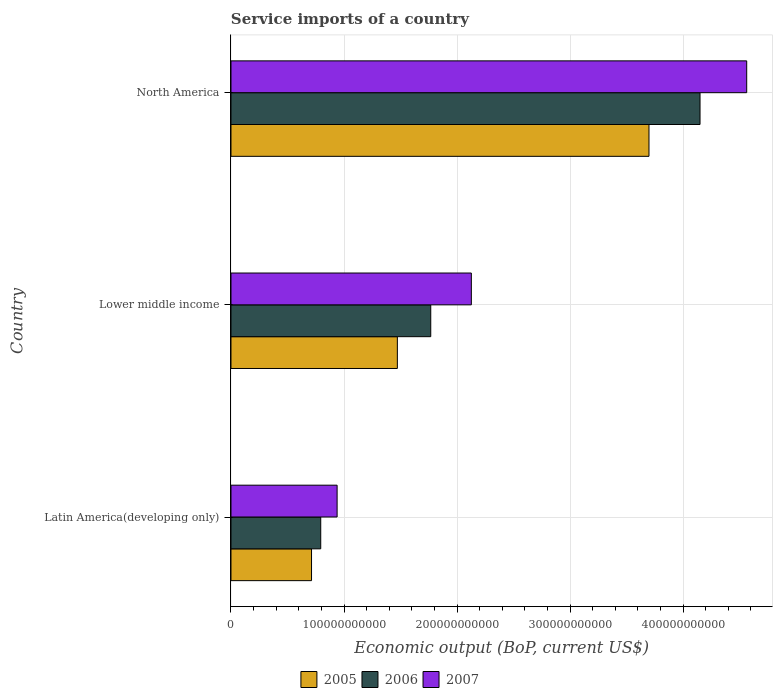How many different coloured bars are there?
Provide a short and direct response. 3. How many groups of bars are there?
Give a very brief answer. 3. Are the number of bars per tick equal to the number of legend labels?
Provide a short and direct response. Yes. What is the service imports in 2006 in Lower middle income?
Ensure brevity in your answer.  1.77e+11. Across all countries, what is the maximum service imports in 2005?
Keep it short and to the point. 3.70e+11. Across all countries, what is the minimum service imports in 2005?
Give a very brief answer. 7.13e+1. In which country was the service imports in 2005 minimum?
Offer a very short reply. Latin America(developing only). What is the total service imports in 2005 in the graph?
Offer a terse response. 5.88e+11. What is the difference between the service imports in 2006 in Lower middle income and that in North America?
Make the answer very short. -2.38e+11. What is the difference between the service imports in 2007 in Lower middle income and the service imports in 2006 in North America?
Offer a terse response. -2.02e+11. What is the average service imports in 2005 per country?
Give a very brief answer. 1.96e+11. What is the difference between the service imports in 2006 and service imports in 2007 in North America?
Ensure brevity in your answer.  -4.13e+1. In how many countries, is the service imports in 2007 greater than 440000000000 US$?
Give a very brief answer. 1. What is the ratio of the service imports in 2005 in Latin America(developing only) to that in North America?
Offer a very short reply. 0.19. Is the service imports in 2005 in Latin America(developing only) less than that in Lower middle income?
Your answer should be very brief. Yes. What is the difference between the highest and the second highest service imports in 2007?
Provide a succinct answer. 2.44e+11. What is the difference between the highest and the lowest service imports in 2007?
Provide a short and direct response. 3.62e+11. In how many countries, is the service imports in 2005 greater than the average service imports in 2005 taken over all countries?
Your answer should be compact. 1. Is it the case that in every country, the sum of the service imports in 2007 and service imports in 2005 is greater than the service imports in 2006?
Provide a succinct answer. Yes. What is the difference between two consecutive major ticks on the X-axis?
Keep it short and to the point. 1.00e+11. Does the graph contain any zero values?
Offer a very short reply. No. How are the legend labels stacked?
Keep it short and to the point. Horizontal. What is the title of the graph?
Provide a succinct answer. Service imports of a country. What is the label or title of the X-axis?
Your answer should be very brief. Economic output (BoP, current US$). What is the label or title of the Y-axis?
Keep it short and to the point. Country. What is the Economic output (BoP, current US$) in 2005 in Latin America(developing only)?
Offer a terse response. 7.13e+1. What is the Economic output (BoP, current US$) in 2006 in Latin America(developing only)?
Make the answer very short. 7.94e+1. What is the Economic output (BoP, current US$) in 2007 in Latin America(developing only)?
Offer a very short reply. 9.39e+1. What is the Economic output (BoP, current US$) in 2005 in Lower middle income?
Your answer should be very brief. 1.47e+11. What is the Economic output (BoP, current US$) in 2006 in Lower middle income?
Keep it short and to the point. 1.77e+11. What is the Economic output (BoP, current US$) of 2007 in Lower middle income?
Ensure brevity in your answer.  2.13e+11. What is the Economic output (BoP, current US$) in 2005 in North America?
Make the answer very short. 3.70e+11. What is the Economic output (BoP, current US$) in 2006 in North America?
Provide a short and direct response. 4.15e+11. What is the Economic output (BoP, current US$) in 2007 in North America?
Ensure brevity in your answer.  4.56e+11. Across all countries, what is the maximum Economic output (BoP, current US$) of 2005?
Your response must be concise. 3.70e+11. Across all countries, what is the maximum Economic output (BoP, current US$) of 2006?
Provide a short and direct response. 4.15e+11. Across all countries, what is the maximum Economic output (BoP, current US$) in 2007?
Offer a very short reply. 4.56e+11. Across all countries, what is the minimum Economic output (BoP, current US$) in 2005?
Make the answer very short. 7.13e+1. Across all countries, what is the minimum Economic output (BoP, current US$) of 2006?
Provide a succinct answer. 7.94e+1. Across all countries, what is the minimum Economic output (BoP, current US$) of 2007?
Make the answer very short. 9.39e+1. What is the total Economic output (BoP, current US$) of 2005 in the graph?
Your response must be concise. 5.88e+11. What is the total Economic output (BoP, current US$) of 2006 in the graph?
Your answer should be compact. 6.71e+11. What is the total Economic output (BoP, current US$) of 2007 in the graph?
Keep it short and to the point. 7.63e+11. What is the difference between the Economic output (BoP, current US$) in 2005 in Latin America(developing only) and that in Lower middle income?
Provide a succinct answer. -7.59e+1. What is the difference between the Economic output (BoP, current US$) of 2006 in Latin America(developing only) and that in Lower middle income?
Keep it short and to the point. -9.73e+1. What is the difference between the Economic output (BoP, current US$) in 2007 in Latin America(developing only) and that in Lower middle income?
Provide a succinct answer. -1.19e+11. What is the difference between the Economic output (BoP, current US$) in 2005 in Latin America(developing only) and that in North America?
Your response must be concise. -2.99e+11. What is the difference between the Economic output (BoP, current US$) of 2006 in Latin America(developing only) and that in North America?
Offer a very short reply. -3.36e+11. What is the difference between the Economic output (BoP, current US$) in 2007 in Latin America(developing only) and that in North America?
Provide a succinct answer. -3.62e+11. What is the difference between the Economic output (BoP, current US$) in 2005 in Lower middle income and that in North America?
Make the answer very short. -2.23e+11. What is the difference between the Economic output (BoP, current US$) in 2006 in Lower middle income and that in North America?
Your response must be concise. -2.38e+11. What is the difference between the Economic output (BoP, current US$) of 2007 in Lower middle income and that in North America?
Offer a terse response. -2.44e+11. What is the difference between the Economic output (BoP, current US$) in 2005 in Latin America(developing only) and the Economic output (BoP, current US$) in 2006 in Lower middle income?
Provide a succinct answer. -1.05e+11. What is the difference between the Economic output (BoP, current US$) of 2005 in Latin America(developing only) and the Economic output (BoP, current US$) of 2007 in Lower middle income?
Provide a succinct answer. -1.41e+11. What is the difference between the Economic output (BoP, current US$) of 2006 in Latin America(developing only) and the Economic output (BoP, current US$) of 2007 in Lower middle income?
Offer a terse response. -1.33e+11. What is the difference between the Economic output (BoP, current US$) of 2005 in Latin America(developing only) and the Economic output (BoP, current US$) of 2006 in North America?
Your answer should be very brief. -3.44e+11. What is the difference between the Economic output (BoP, current US$) of 2005 in Latin America(developing only) and the Economic output (BoP, current US$) of 2007 in North America?
Your answer should be very brief. -3.85e+11. What is the difference between the Economic output (BoP, current US$) in 2006 in Latin America(developing only) and the Economic output (BoP, current US$) in 2007 in North America?
Your answer should be compact. -3.77e+11. What is the difference between the Economic output (BoP, current US$) of 2005 in Lower middle income and the Economic output (BoP, current US$) of 2006 in North America?
Offer a terse response. -2.68e+11. What is the difference between the Economic output (BoP, current US$) of 2005 in Lower middle income and the Economic output (BoP, current US$) of 2007 in North America?
Keep it short and to the point. -3.09e+11. What is the difference between the Economic output (BoP, current US$) of 2006 in Lower middle income and the Economic output (BoP, current US$) of 2007 in North America?
Keep it short and to the point. -2.80e+11. What is the average Economic output (BoP, current US$) in 2005 per country?
Your response must be concise. 1.96e+11. What is the average Economic output (BoP, current US$) of 2006 per country?
Your answer should be very brief. 2.24e+11. What is the average Economic output (BoP, current US$) of 2007 per country?
Give a very brief answer. 2.54e+11. What is the difference between the Economic output (BoP, current US$) of 2005 and Economic output (BoP, current US$) of 2006 in Latin America(developing only)?
Offer a very short reply. -8.14e+09. What is the difference between the Economic output (BoP, current US$) in 2005 and Economic output (BoP, current US$) in 2007 in Latin America(developing only)?
Ensure brevity in your answer.  -2.26e+1. What is the difference between the Economic output (BoP, current US$) of 2006 and Economic output (BoP, current US$) of 2007 in Latin America(developing only)?
Make the answer very short. -1.45e+1. What is the difference between the Economic output (BoP, current US$) in 2005 and Economic output (BoP, current US$) in 2006 in Lower middle income?
Provide a short and direct response. -2.95e+1. What is the difference between the Economic output (BoP, current US$) in 2005 and Economic output (BoP, current US$) in 2007 in Lower middle income?
Your answer should be very brief. -6.55e+1. What is the difference between the Economic output (BoP, current US$) of 2006 and Economic output (BoP, current US$) of 2007 in Lower middle income?
Your answer should be very brief. -3.59e+1. What is the difference between the Economic output (BoP, current US$) in 2005 and Economic output (BoP, current US$) in 2006 in North America?
Ensure brevity in your answer.  -4.52e+1. What is the difference between the Economic output (BoP, current US$) in 2005 and Economic output (BoP, current US$) in 2007 in North America?
Offer a very short reply. -8.65e+1. What is the difference between the Economic output (BoP, current US$) of 2006 and Economic output (BoP, current US$) of 2007 in North America?
Your answer should be compact. -4.13e+1. What is the ratio of the Economic output (BoP, current US$) in 2005 in Latin America(developing only) to that in Lower middle income?
Ensure brevity in your answer.  0.48. What is the ratio of the Economic output (BoP, current US$) of 2006 in Latin America(developing only) to that in Lower middle income?
Offer a very short reply. 0.45. What is the ratio of the Economic output (BoP, current US$) of 2007 in Latin America(developing only) to that in Lower middle income?
Your response must be concise. 0.44. What is the ratio of the Economic output (BoP, current US$) in 2005 in Latin America(developing only) to that in North America?
Your response must be concise. 0.19. What is the ratio of the Economic output (BoP, current US$) in 2006 in Latin America(developing only) to that in North America?
Provide a succinct answer. 0.19. What is the ratio of the Economic output (BoP, current US$) of 2007 in Latin America(developing only) to that in North America?
Keep it short and to the point. 0.21. What is the ratio of the Economic output (BoP, current US$) of 2005 in Lower middle income to that in North America?
Your response must be concise. 0.4. What is the ratio of the Economic output (BoP, current US$) in 2006 in Lower middle income to that in North America?
Ensure brevity in your answer.  0.43. What is the ratio of the Economic output (BoP, current US$) in 2007 in Lower middle income to that in North America?
Ensure brevity in your answer.  0.47. What is the difference between the highest and the second highest Economic output (BoP, current US$) in 2005?
Your answer should be compact. 2.23e+11. What is the difference between the highest and the second highest Economic output (BoP, current US$) in 2006?
Offer a very short reply. 2.38e+11. What is the difference between the highest and the second highest Economic output (BoP, current US$) in 2007?
Provide a succinct answer. 2.44e+11. What is the difference between the highest and the lowest Economic output (BoP, current US$) in 2005?
Provide a short and direct response. 2.99e+11. What is the difference between the highest and the lowest Economic output (BoP, current US$) of 2006?
Your response must be concise. 3.36e+11. What is the difference between the highest and the lowest Economic output (BoP, current US$) of 2007?
Offer a terse response. 3.62e+11. 